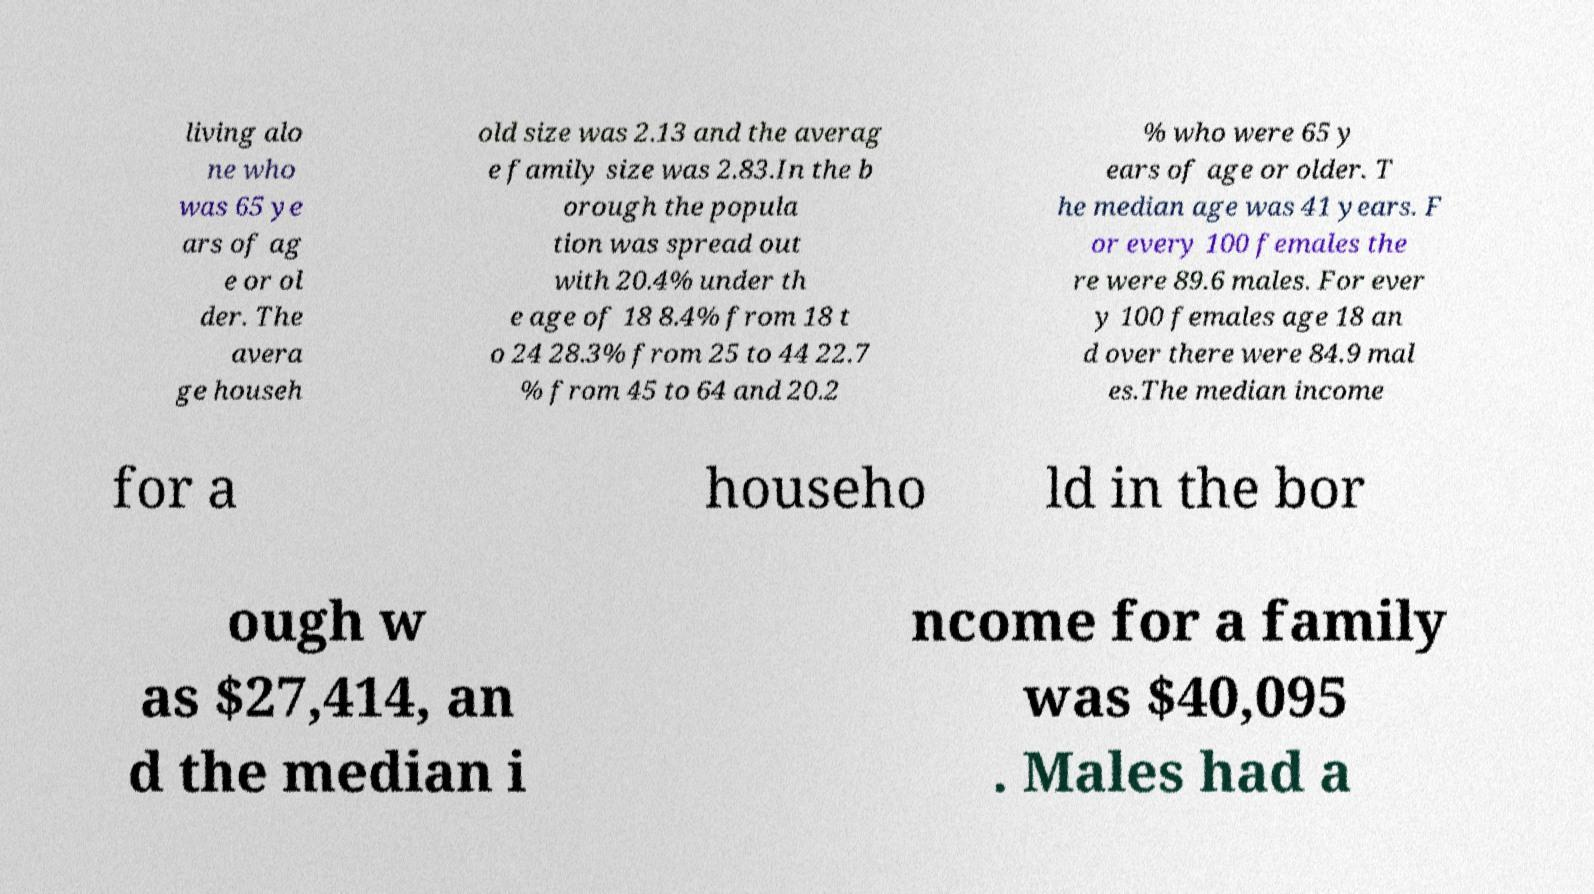Please identify and transcribe the text found in this image. living alo ne who was 65 ye ars of ag e or ol der. The avera ge househ old size was 2.13 and the averag e family size was 2.83.In the b orough the popula tion was spread out with 20.4% under th e age of 18 8.4% from 18 t o 24 28.3% from 25 to 44 22.7 % from 45 to 64 and 20.2 % who were 65 y ears of age or older. T he median age was 41 years. F or every 100 females the re were 89.6 males. For ever y 100 females age 18 an d over there were 84.9 mal es.The median income for a househo ld in the bor ough w as $27,414, an d the median i ncome for a family was $40,095 . Males had a 